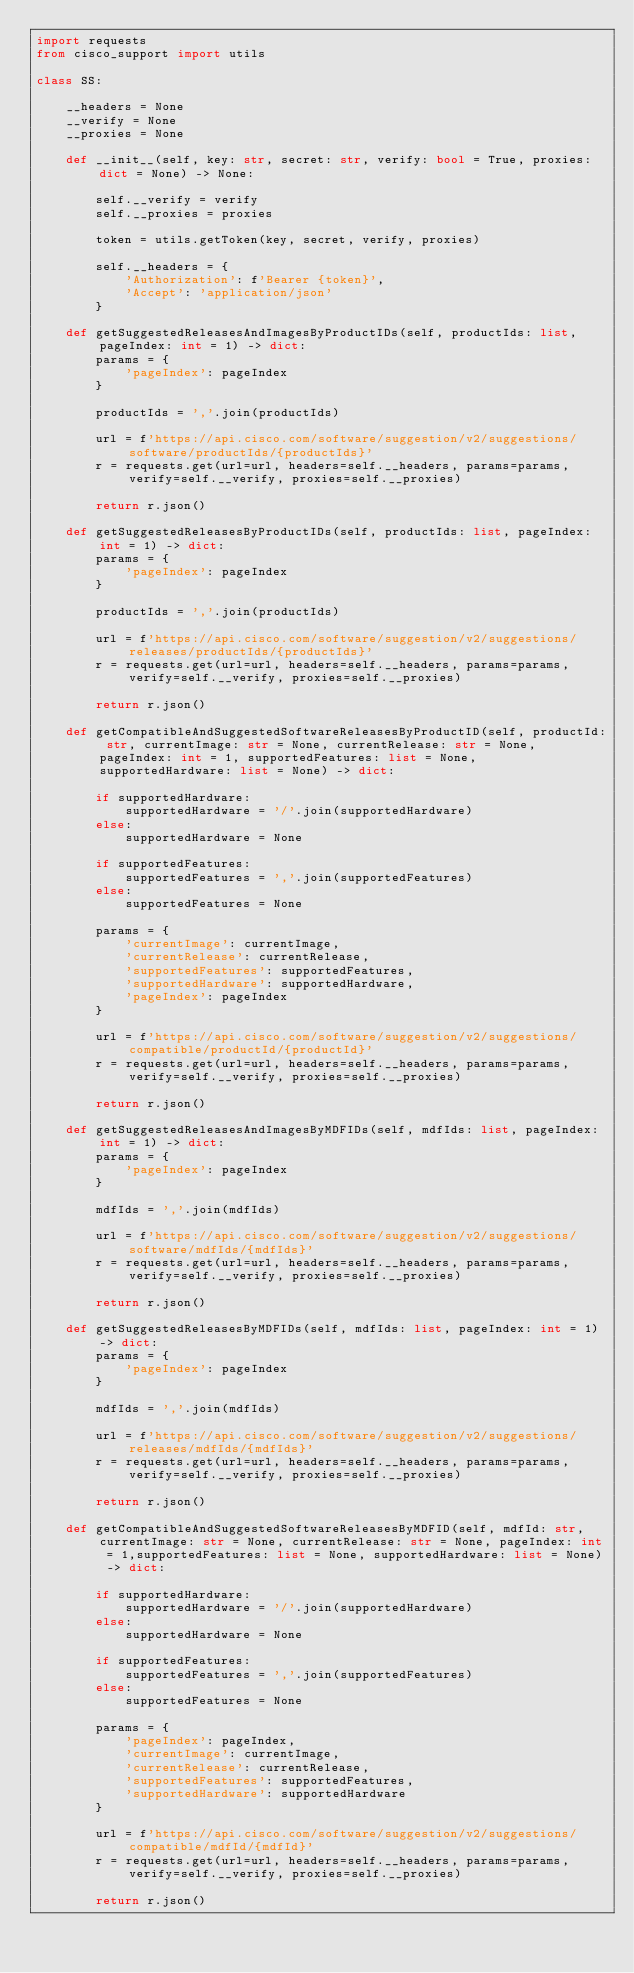<code> <loc_0><loc_0><loc_500><loc_500><_Python_>import requests
from cisco_support import utils

class SS:

    __headers = None
    __verify = None
    __proxies = None

    def __init__(self, key: str, secret: str, verify: bool = True, proxies: dict = None) -> None:

        self.__verify = verify
        self.__proxies = proxies

        token = utils.getToken(key, secret, verify, proxies)      

        self.__headers = {
            'Authorization': f'Bearer {token}',
            'Accept': 'application/json'
        }

    def getSuggestedReleasesAndImagesByProductIDs(self, productIds: list, pageIndex: int = 1) -> dict:
        params = {
            'pageIndex': pageIndex
        }

        productIds = ','.join(productIds)

        url = f'https://api.cisco.com/software/suggestion/v2/suggestions/software/productIds/{productIds}'
        r = requests.get(url=url, headers=self.__headers, params=params, verify=self.__verify, proxies=self.__proxies)

        return r.json()

    def getSuggestedReleasesByProductIDs(self, productIds: list, pageIndex: int = 1) -> dict:
        params = {
            'pageIndex': pageIndex
        }

        productIds = ','.join(productIds)

        url = f'https://api.cisco.com/software/suggestion/v2/suggestions/releases/productIds/{productIds}'
        r = requests.get(url=url, headers=self.__headers, params=params, verify=self.__verify, proxies=self.__proxies)

        return r.json()

    def getCompatibleAndSuggestedSoftwareReleasesByProductID(self, productId: str, currentImage: str = None, currentRelease: str = None, pageIndex: int = 1, supportedFeatures: list = None, supportedHardware: list = None) -> dict:
        
        if supportedHardware:
            supportedHardware = '/'.join(supportedHardware)
        else:
            supportedHardware = None

        if supportedFeatures:
            supportedFeatures = ','.join(supportedFeatures)
        else:
            supportedFeatures = None
        
        params = {
            'currentImage': currentImage,
            'currentRelease': currentRelease,
            'supportedFeatures': supportedFeatures,
            'supportedHardware': supportedHardware,
            'pageIndex': pageIndex
        }

        url = f'https://api.cisco.com/software/suggestion/v2/suggestions/compatible/productId/{productId}'
        r = requests.get(url=url, headers=self.__headers, params=params, verify=self.__verify, proxies=self.__proxies)

        return r.json()

    def getSuggestedReleasesAndImagesByMDFIDs(self, mdfIds: list, pageIndex: int = 1) -> dict:
        params = {
            'pageIndex': pageIndex
        }

        mdfIds = ','.join(mdfIds)

        url = f'https://api.cisco.com/software/suggestion/v2/suggestions/software/mdfIds/{mdfIds}'
        r = requests.get(url=url, headers=self.__headers, params=params, verify=self.__verify, proxies=self.__proxies)

        return r.json()

    def getSuggestedReleasesByMDFIDs(self, mdfIds: list, pageIndex: int = 1) -> dict:
        params = {
            'pageIndex': pageIndex
        }

        mdfIds = ','.join(mdfIds)

        url = f'https://api.cisco.com/software/suggestion/v2/suggestions/releases/mdfIds/{mdfIds}'
        r = requests.get(url=url, headers=self.__headers, params=params, verify=self.__verify, proxies=self.__proxies)

        return r.json()

    def getCompatibleAndSuggestedSoftwareReleasesByMDFID(self, mdfId: str, currentImage: str = None, currentRelease: str = None, pageIndex: int = 1,supportedFeatures: list = None, supportedHardware: list = None) -> dict:
        
        if supportedHardware:
            supportedHardware = '/'.join(supportedHardware)
        else:
            supportedHardware = None

        if supportedFeatures:
            supportedFeatures = ','.join(supportedFeatures)
        else:
            supportedFeatures = None
        
        params = {
            'pageIndex': pageIndex,
            'currentImage': currentImage,
            'currentRelease': currentRelease,
            'supportedFeatures': supportedFeatures,
            'supportedHardware': supportedHardware
        }

        url = f'https://api.cisco.com/software/suggestion/v2/suggestions/compatible/mdfId/{mdfId}'
        r = requests.get(url=url, headers=self.__headers, params=params, verify=self.__verify, proxies=self.__proxies)

        return r.json()</code> 